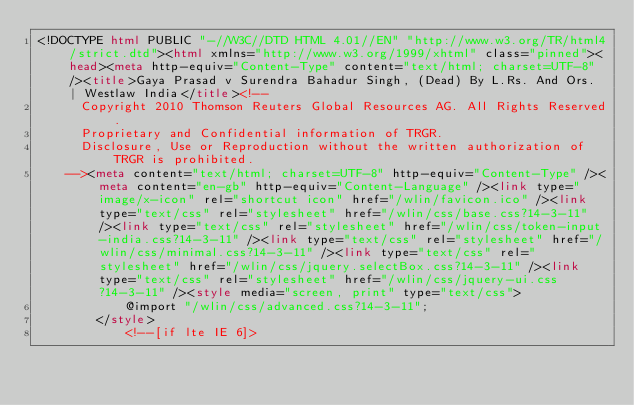Convert code to text. <code><loc_0><loc_0><loc_500><loc_500><_HTML_><!DOCTYPE html PUBLIC "-//W3C//DTD HTML 4.01//EN" "http://www.w3.org/TR/html4/strict.dtd"><html xmlns="http://www.w3.org/1999/xhtml" class="pinned"><head><meta http-equiv="Content-Type" content="text/html; charset=UTF-8" /><title>Gaya Prasad v Surendra Bahadur Singh, (Dead) By L.Rs. And Ors. | Westlaw India</title><!--
      Copyright 2010 Thomson Reuters Global Resources AG. All Rights Reserved.
      Proprietary and Confidential information of TRGR.
      Disclosure, Use or Reproduction without the written authorization of TRGR is prohibited.
    --><meta content="text/html; charset=UTF-8" http-equiv="Content-Type" /><meta content="en-gb" http-equiv="Content-Language" /><link type="image/x-icon" rel="shortcut icon" href="/wlin/favicon.ico" /><link type="text/css" rel="stylesheet" href="/wlin/css/base.css?14-3-11" /><link type="text/css" rel="stylesheet" href="/wlin/css/token-input-india.css?14-3-11" /><link type="text/css" rel="stylesheet" href="/wlin/css/minimal.css?14-3-11" /><link type="text/css" rel="stylesheet" href="/wlin/css/jquery.selectBox.css?14-3-11" /><link type="text/css" rel="stylesheet" href="/wlin/css/jquery-ui.css?14-3-11" /><style media="screen, print" type="text/css">
			@import "/wlin/css/advanced.css?14-3-11";
		</style>
			<!--[if lte IE 6]></code> 